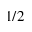<formula> <loc_0><loc_0><loc_500><loc_500>1 / 2</formula> 